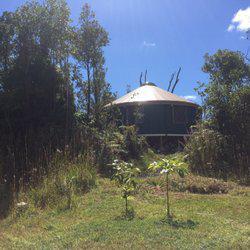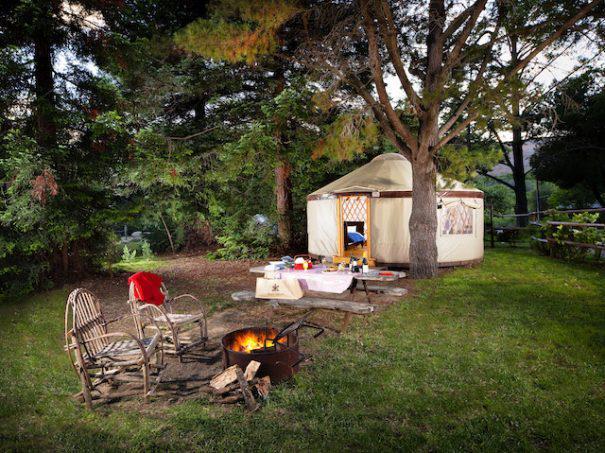The first image is the image on the left, the second image is the image on the right. For the images displayed, is the sentence "There are four or more yurts in the left image and some of them are red." factually correct? Answer yes or no. No. The first image is the image on the left, the second image is the image on the right. For the images displayed, is the sentence "Two round houses with white roofs and walls are in one image." factually correct? Answer yes or no. No. 